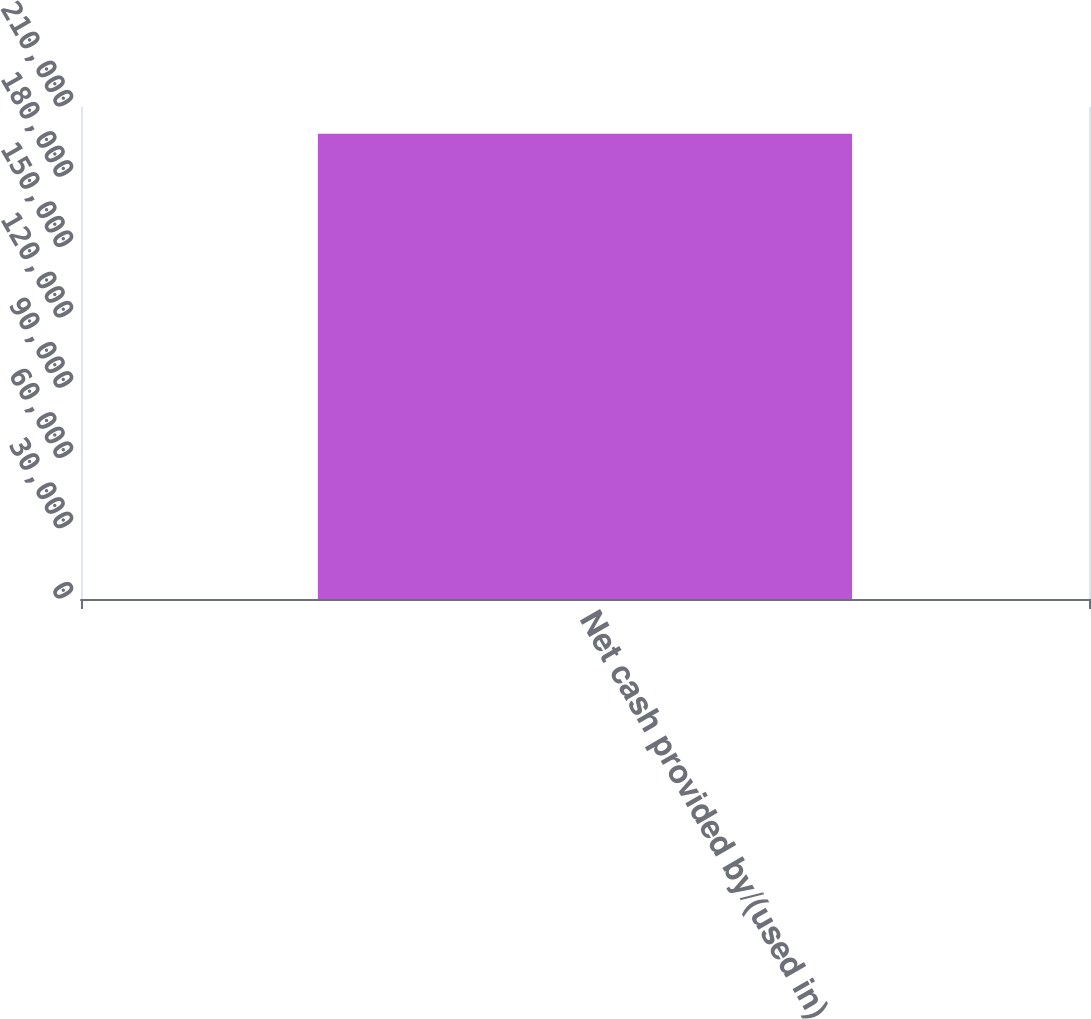<chart> <loc_0><loc_0><loc_500><loc_500><bar_chart><fcel>Net cash provided by/(used in)<nl><fcel>198559<nl></chart> 